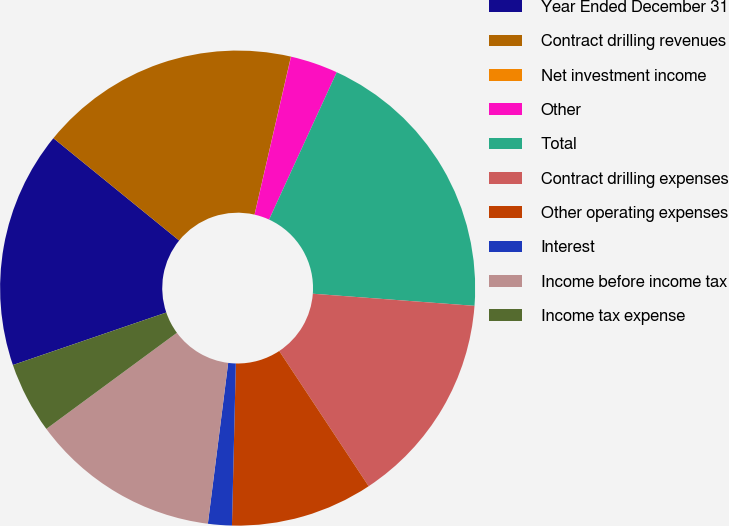<chart> <loc_0><loc_0><loc_500><loc_500><pie_chart><fcel>Year Ended December 31<fcel>Contract drilling revenues<fcel>Net investment income<fcel>Other<fcel>Total<fcel>Contract drilling expenses<fcel>Other operating expenses<fcel>Interest<fcel>Income before income tax<fcel>Income tax expense<nl><fcel>16.12%<fcel>17.73%<fcel>0.01%<fcel>3.24%<fcel>19.34%<fcel>14.51%<fcel>9.68%<fcel>1.62%<fcel>12.9%<fcel>4.85%<nl></chart> 